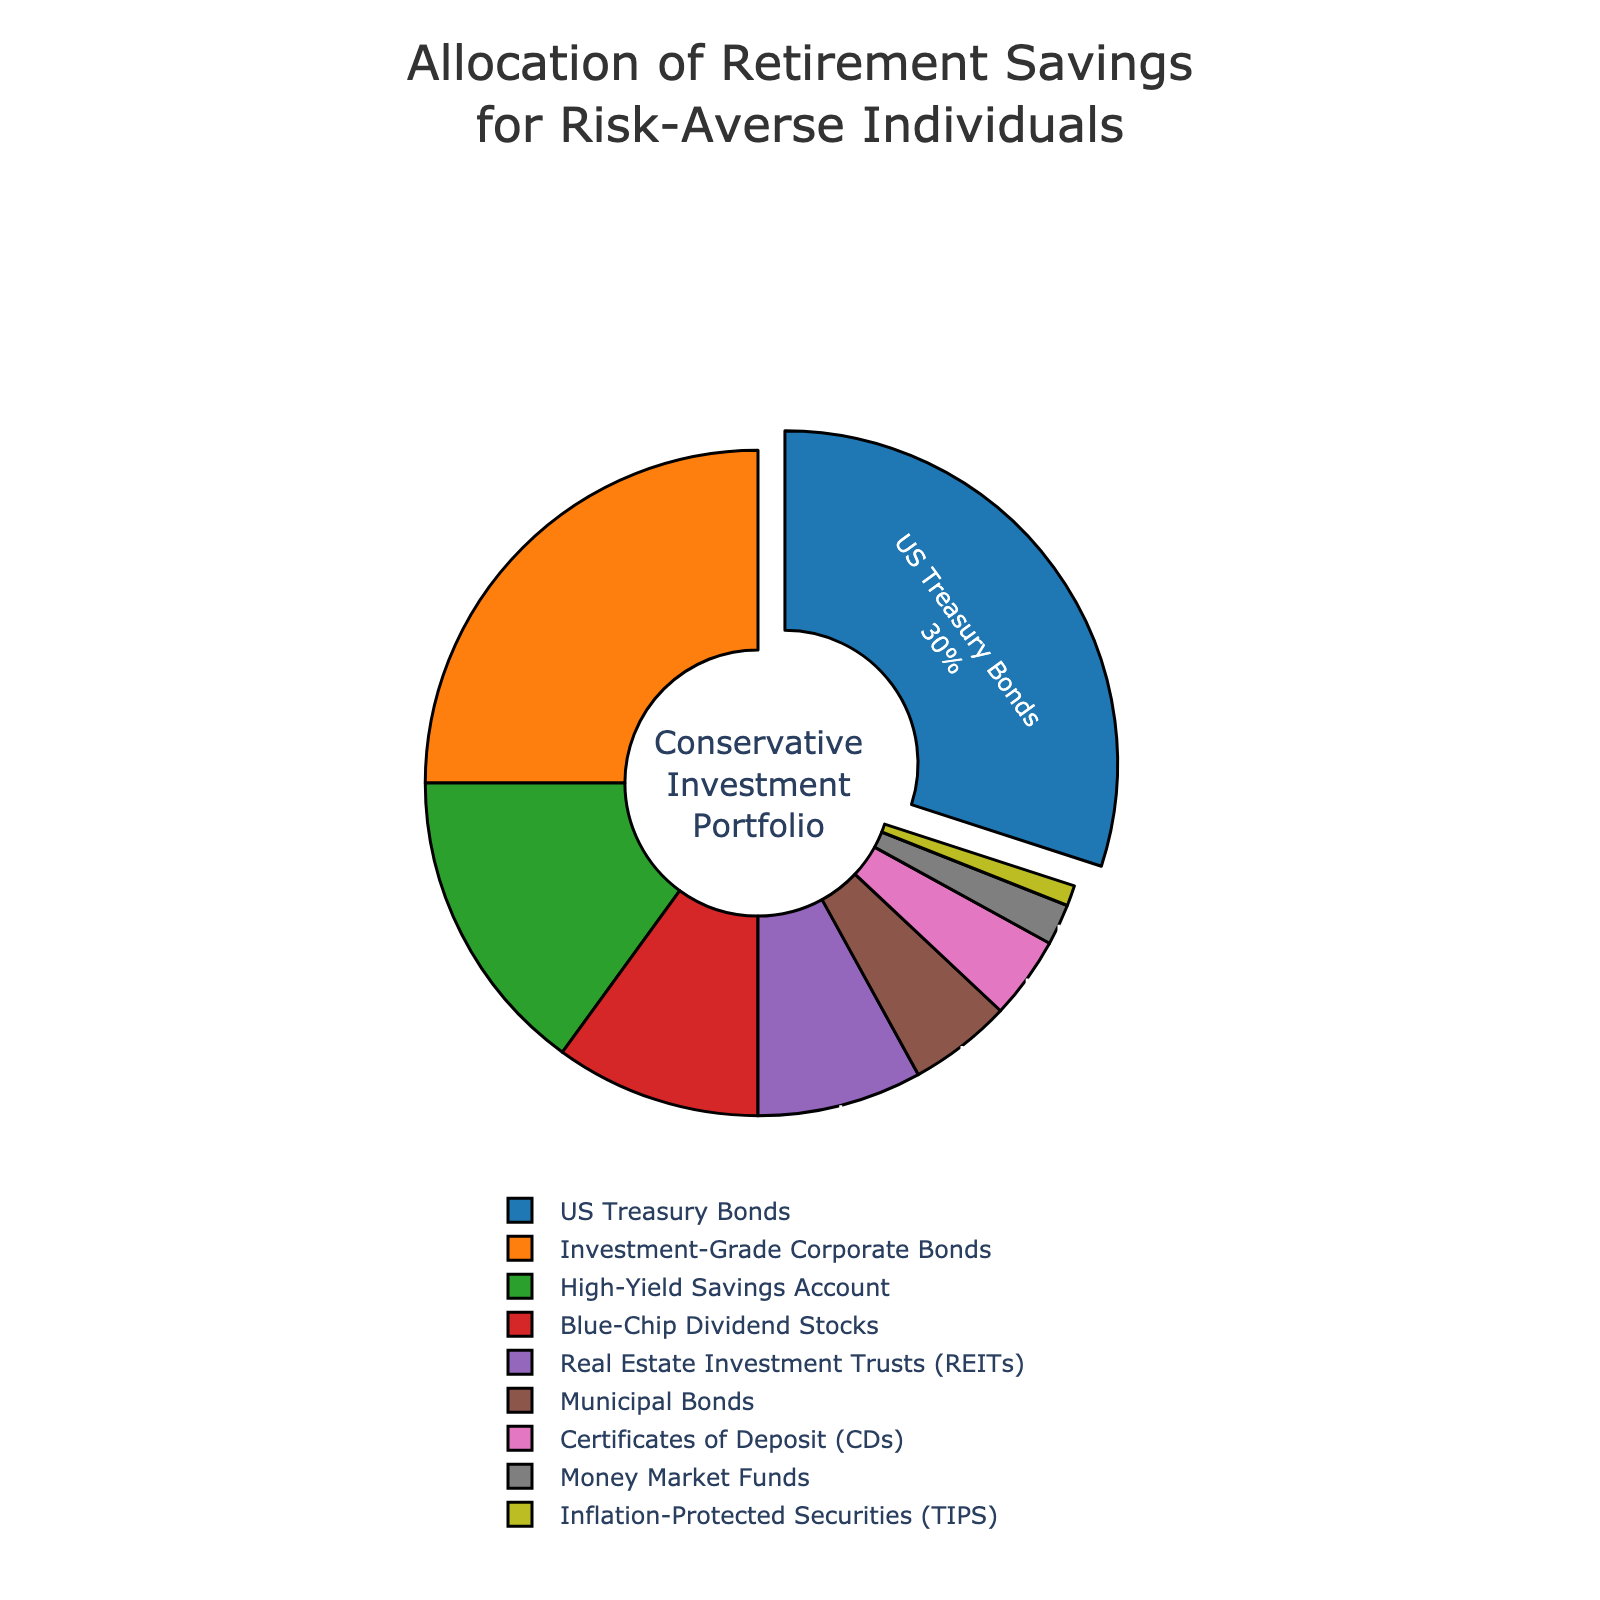Which investment vehicle takes up the largest proportion of the allocation? The section pulled out from the pie chart represents the largest percentage. By observing, we can see that US Treasury Bonds have the largest section pulled out.
Answer: US Treasury Bonds How much more is allocated to US Treasury Bonds compared to Blue-Chip Dividend Stocks? US Treasury Bonds make up 30%, and Blue-Chip Dividend Stocks make up 10%. Subtract the percentage of Blue-Chip Dividend Stocks from US Treasury Bonds: 30% - 10% = 20%.
Answer: 20% Which investment vehicle is represented by the green color? By observing the pie chart, we can identify that Investment-Grade Corporate Bonds are represented by the green color.
Answer: Investment-Grade Corporate Bonds What is the combined allocation percentage for US Treasury Bonds and Investment-Grade Corporate Bonds? US Treasury Bonds have 30%, and Investment-Grade Corporate Bonds have 25%. Adding these two values gives 30% + 25% = 55%.
Answer: 55% Are Real Estate Investment Trusts (REITs) allocated more than Municipal Bonds? By what percentage? The chart shows REITs have 8% and Municipal Bonds have 5%. The difference is 8% - 5% = 3%.
Answer: Yes, 3% Identify the two investment vehicles with the smallest allocations. By looking at the pie chart, the smallest sections correspond to Inflation-Protected Securities (TIPS) with 1% and Money Market Funds with 2%.
Answer: TIPS and Money Market Funds Which investment vehicles combined make up half of the total allocation? US Treasury Bonds (30%) and Investment-Grade Corporate Bonds (25%) together add up to 55%, more than half. Blue-Chip Dividend Stocks (10%) and High-Yield Savings Account (15%) together add up to 25%. Rice REITs (8%), Municipal Bonds (5%), CDs (4%), and Money Market Funds (2%, sum = 19%). Thus, choosing more significant proportions: US Treasury Bonds (30%) and Investment-Grade Corporate Bonds (25%).
Answer: US Treasury Bonds and Investment-Grade Corporate Bonds By how many times is the allocation to Money Market Funds larger than to Inflation-Protected Securities (TIPS)? Money Market Funds have 2%, and Inflation-Protected Securities (TIPS) have 1%. The ratio is 2% / 1% = 2.
Answer: 2 times 